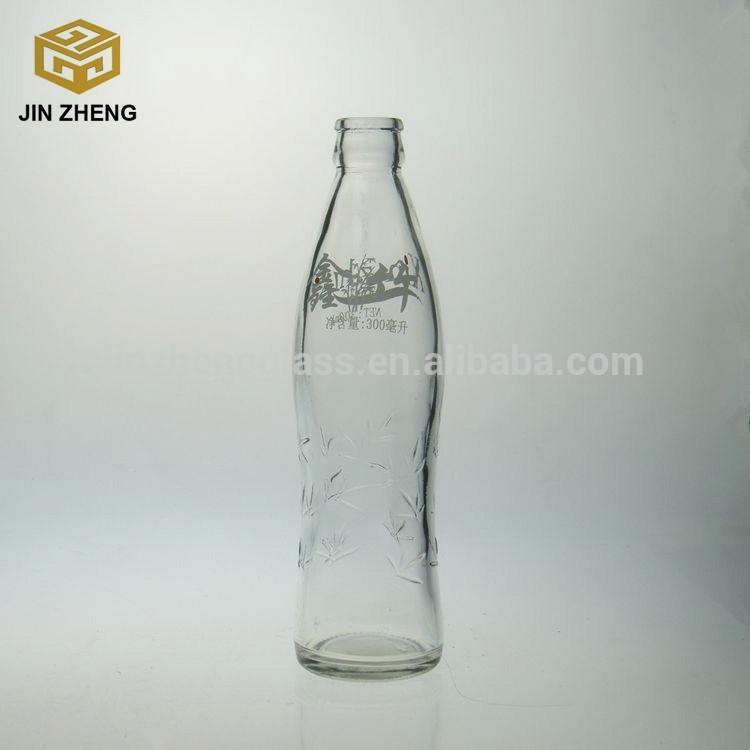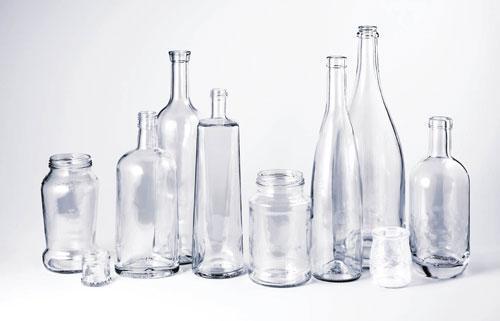The first image is the image on the left, the second image is the image on the right. For the images shown, is this caption "The left image contains a single glass bottle with no label on its bottom half, and the right image contains at least three glass bottles with no labels." true? Answer yes or no. Yes. The first image is the image on the left, the second image is the image on the right. Evaluate the accuracy of this statement regarding the images: "There are two bottles". Is it true? Answer yes or no. No. 